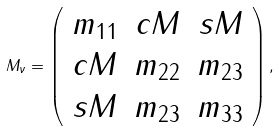Convert formula to latex. <formula><loc_0><loc_0><loc_500><loc_500>M _ { \nu } = \left ( \begin{array} { c c c } m _ { 1 1 } & c M & s M \\ c M & m _ { 2 2 } & m _ { 2 3 } \\ s M & m _ { 2 3 } & m _ { 3 3 } \end{array} \right ) ,</formula> 